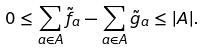Convert formula to latex. <formula><loc_0><loc_0><loc_500><loc_500>0 \leq \sum _ { a \in A } \tilde { f } _ { a } - \sum _ { a \in A } \tilde { g } _ { a } \leq | A | .</formula> 